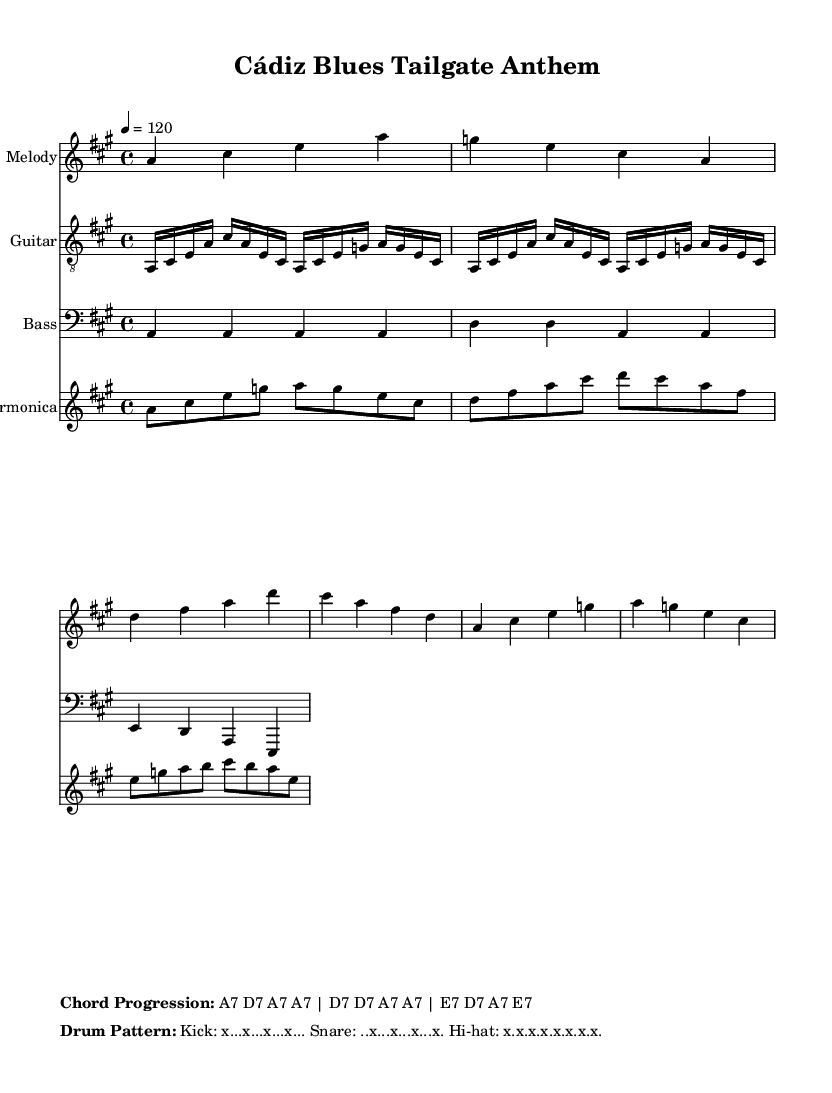What is the key signature of this music? The key signature is A major, which has three sharps: F#, C#, and G#.
Answer: A major What is the time signature of this music? The time signature is indicated at the beginning of the score as four beats per measure.
Answer: 4/4 What is the tempo marking for this piece? The tempo marking at the beginning specifies a speed of 120 beats per minute, indicating the performance should be bright and lively.
Answer: 120 What is the genre of this piece? The piece is an electric blues song, which combines traditional blues elements with electrical instrumentation and lively rhythms suitable for gathering and celebration.
Answer: Electric blues How many sections are there in this song based on the lyrics provided? The song includes both verse and chorus sections, creating a structure typical of many upbeat songs, indicating it has at least two main lyrical parts.
Answer: Two What defines the upbeat nature of this electric blues song? The song features a lively tempo (120 bpm), an energetic drum pattern, and an engaging call-and-response structure typical of electric blues, providing a celebratory atmosphere.
Answer: Upbeat tempo and rhythm 